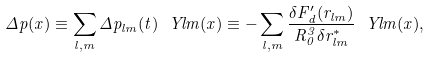<formula> <loc_0><loc_0><loc_500><loc_500>\Delta p ( x ) \equiv \sum _ { l , m } \Delta p _ { l m } ( t ) \ Y l m ( x ) \equiv - \sum _ { l , m } \frac { \delta F _ { d } ^ { \prime } ( r _ { l m } ) } { R _ { 0 } ^ { 3 } \delta r _ { l m } ^ { * } } \ Y l m ( x ) ,</formula> 